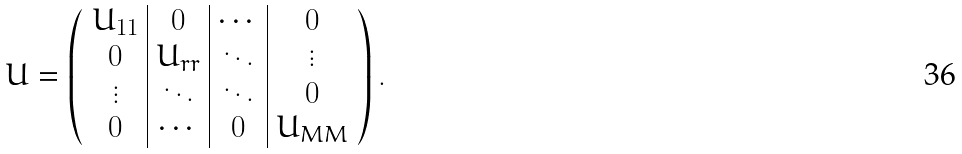<formula> <loc_0><loc_0><loc_500><loc_500>U = \left ( \begin{array} { c | c | c | c } \strut U _ { 1 1 } & { 0 } & \cdots & { 0 } \\ \strut { 0 } & U _ { r r } & \ddots & \vdots \\ \strut \vdots & \ddots & \ddots & { 0 } \\ \strut { 0 } & \cdots & { 0 } & U _ { M M } \end{array} \right ) .</formula> 